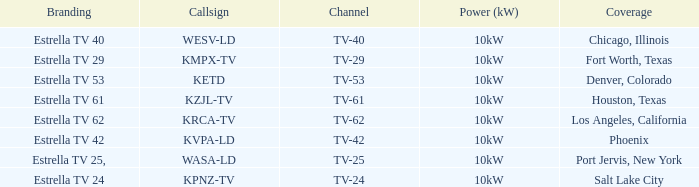What is the branding name for tv channel 62? Estrella TV 62. 